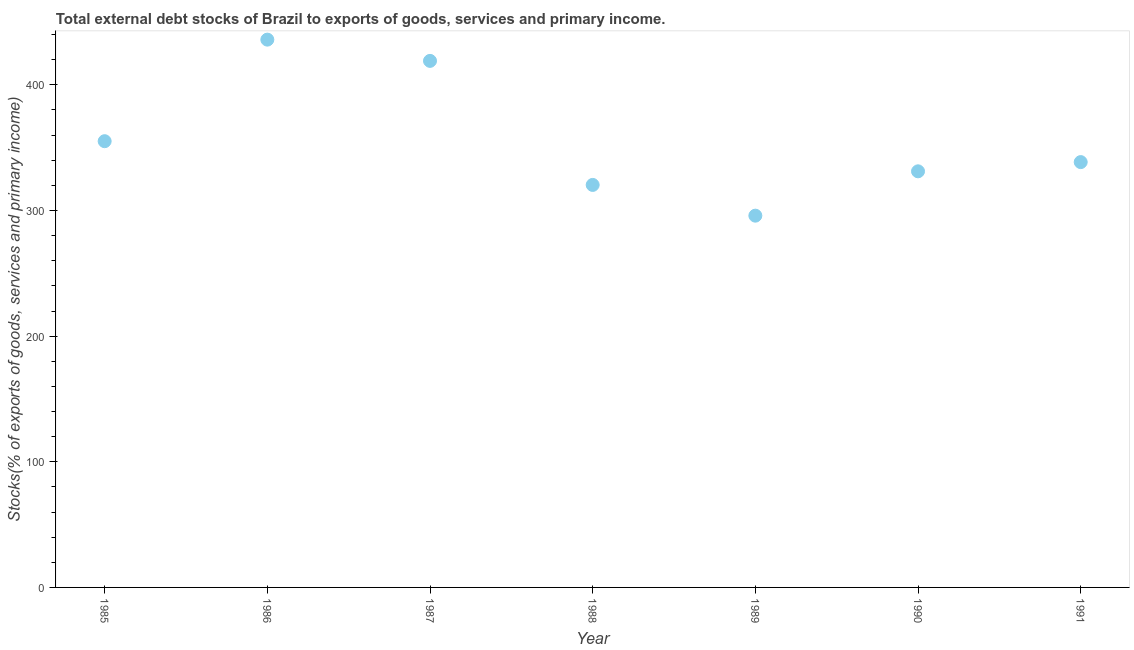What is the external debt stocks in 1989?
Make the answer very short. 295.89. Across all years, what is the maximum external debt stocks?
Give a very brief answer. 436.01. Across all years, what is the minimum external debt stocks?
Provide a short and direct response. 295.89. What is the sum of the external debt stocks?
Give a very brief answer. 2496.23. What is the difference between the external debt stocks in 1985 and 1987?
Your response must be concise. -63.92. What is the average external debt stocks per year?
Make the answer very short. 356.6. What is the median external debt stocks?
Offer a terse response. 338.53. In how many years, is the external debt stocks greater than 320 %?
Ensure brevity in your answer.  6. What is the ratio of the external debt stocks in 1986 to that in 1987?
Offer a terse response. 1.04. What is the difference between the highest and the second highest external debt stocks?
Ensure brevity in your answer.  16.92. What is the difference between the highest and the lowest external debt stocks?
Your response must be concise. 140.11. In how many years, is the external debt stocks greater than the average external debt stocks taken over all years?
Provide a succinct answer. 2. How many dotlines are there?
Offer a terse response. 1. What is the difference between two consecutive major ticks on the Y-axis?
Offer a very short reply. 100. Does the graph contain grids?
Offer a very short reply. No. What is the title of the graph?
Offer a very short reply. Total external debt stocks of Brazil to exports of goods, services and primary income. What is the label or title of the X-axis?
Make the answer very short. Year. What is the label or title of the Y-axis?
Provide a short and direct response. Stocks(% of exports of goods, services and primary income). What is the Stocks(% of exports of goods, services and primary income) in 1985?
Give a very brief answer. 355.17. What is the Stocks(% of exports of goods, services and primary income) in 1986?
Your response must be concise. 436.01. What is the Stocks(% of exports of goods, services and primary income) in 1987?
Your answer should be very brief. 419.09. What is the Stocks(% of exports of goods, services and primary income) in 1988?
Make the answer very short. 320.36. What is the Stocks(% of exports of goods, services and primary income) in 1989?
Your answer should be very brief. 295.89. What is the Stocks(% of exports of goods, services and primary income) in 1990?
Your response must be concise. 331.19. What is the Stocks(% of exports of goods, services and primary income) in 1991?
Make the answer very short. 338.53. What is the difference between the Stocks(% of exports of goods, services and primary income) in 1985 and 1986?
Provide a short and direct response. -80.84. What is the difference between the Stocks(% of exports of goods, services and primary income) in 1985 and 1987?
Offer a very short reply. -63.92. What is the difference between the Stocks(% of exports of goods, services and primary income) in 1985 and 1988?
Your answer should be very brief. 34.81. What is the difference between the Stocks(% of exports of goods, services and primary income) in 1985 and 1989?
Your answer should be very brief. 59.27. What is the difference between the Stocks(% of exports of goods, services and primary income) in 1985 and 1990?
Provide a succinct answer. 23.98. What is the difference between the Stocks(% of exports of goods, services and primary income) in 1985 and 1991?
Give a very brief answer. 16.64. What is the difference between the Stocks(% of exports of goods, services and primary income) in 1986 and 1987?
Provide a short and direct response. 16.92. What is the difference between the Stocks(% of exports of goods, services and primary income) in 1986 and 1988?
Ensure brevity in your answer.  115.64. What is the difference between the Stocks(% of exports of goods, services and primary income) in 1986 and 1989?
Your answer should be compact. 140.11. What is the difference between the Stocks(% of exports of goods, services and primary income) in 1986 and 1990?
Make the answer very short. 104.82. What is the difference between the Stocks(% of exports of goods, services and primary income) in 1986 and 1991?
Your answer should be very brief. 97.48. What is the difference between the Stocks(% of exports of goods, services and primary income) in 1987 and 1988?
Provide a succinct answer. 98.73. What is the difference between the Stocks(% of exports of goods, services and primary income) in 1987 and 1989?
Your answer should be very brief. 123.19. What is the difference between the Stocks(% of exports of goods, services and primary income) in 1987 and 1990?
Your answer should be very brief. 87.9. What is the difference between the Stocks(% of exports of goods, services and primary income) in 1987 and 1991?
Offer a terse response. 80.56. What is the difference between the Stocks(% of exports of goods, services and primary income) in 1988 and 1989?
Your response must be concise. 24.47. What is the difference between the Stocks(% of exports of goods, services and primary income) in 1988 and 1990?
Your answer should be compact. -10.82. What is the difference between the Stocks(% of exports of goods, services and primary income) in 1988 and 1991?
Your answer should be compact. -18.16. What is the difference between the Stocks(% of exports of goods, services and primary income) in 1989 and 1990?
Provide a short and direct response. -35.29. What is the difference between the Stocks(% of exports of goods, services and primary income) in 1989 and 1991?
Keep it short and to the point. -42.63. What is the difference between the Stocks(% of exports of goods, services and primary income) in 1990 and 1991?
Make the answer very short. -7.34. What is the ratio of the Stocks(% of exports of goods, services and primary income) in 1985 to that in 1986?
Provide a short and direct response. 0.81. What is the ratio of the Stocks(% of exports of goods, services and primary income) in 1985 to that in 1987?
Give a very brief answer. 0.85. What is the ratio of the Stocks(% of exports of goods, services and primary income) in 1985 to that in 1988?
Your answer should be compact. 1.11. What is the ratio of the Stocks(% of exports of goods, services and primary income) in 1985 to that in 1990?
Provide a succinct answer. 1.07. What is the ratio of the Stocks(% of exports of goods, services and primary income) in 1985 to that in 1991?
Keep it short and to the point. 1.05. What is the ratio of the Stocks(% of exports of goods, services and primary income) in 1986 to that in 1988?
Your response must be concise. 1.36. What is the ratio of the Stocks(% of exports of goods, services and primary income) in 1986 to that in 1989?
Make the answer very short. 1.47. What is the ratio of the Stocks(% of exports of goods, services and primary income) in 1986 to that in 1990?
Your answer should be very brief. 1.32. What is the ratio of the Stocks(% of exports of goods, services and primary income) in 1986 to that in 1991?
Provide a short and direct response. 1.29. What is the ratio of the Stocks(% of exports of goods, services and primary income) in 1987 to that in 1988?
Your response must be concise. 1.31. What is the ratio of the Stocks(% of exports of goods, services and primary income) in 1987 to that in 1989?
Give a very brief answer. 1.42. What is the ratio of the Stocks(% of exports of goods, services and primary income) in 1987 to that in 1990?
Make the answer very short. 1.26. What is the ratio of the Stocks(% of exports of goods, services and primary income) in 1987 to that in 1991?
Your response must be concise. 1.24. What is the ratio of the Stocks(% of exports of goods, services and primary income) in 1988 to that in 1989?
Your answer should be very brief. 1.08. What is the ratio of the Stocks(% of exports of goods, services and primary income) in 1988 to that in 1990?
Your answer should be very brief. 0.97. What is the ratio of the Stocks(% of exports of goods, services and primary income) in 1988 to that in 1991?
Provide a short and direct response. 0.95. What is the ratio of the Stocks(% of exports of goods, services and primary income) in 1989 to that in 1990?
Ensure brevity in your answer.  0.89. What is the ratio of the Stocks(% of exports of goods, services and primary income) in 1989 to that in 1991?
Keep it short and to the point. 0.87. What is the ratio of the Stocks(% of exports of goods, services and primary income) in 1990 to that in 1991?
Provide a short and direct response. 0.98. 